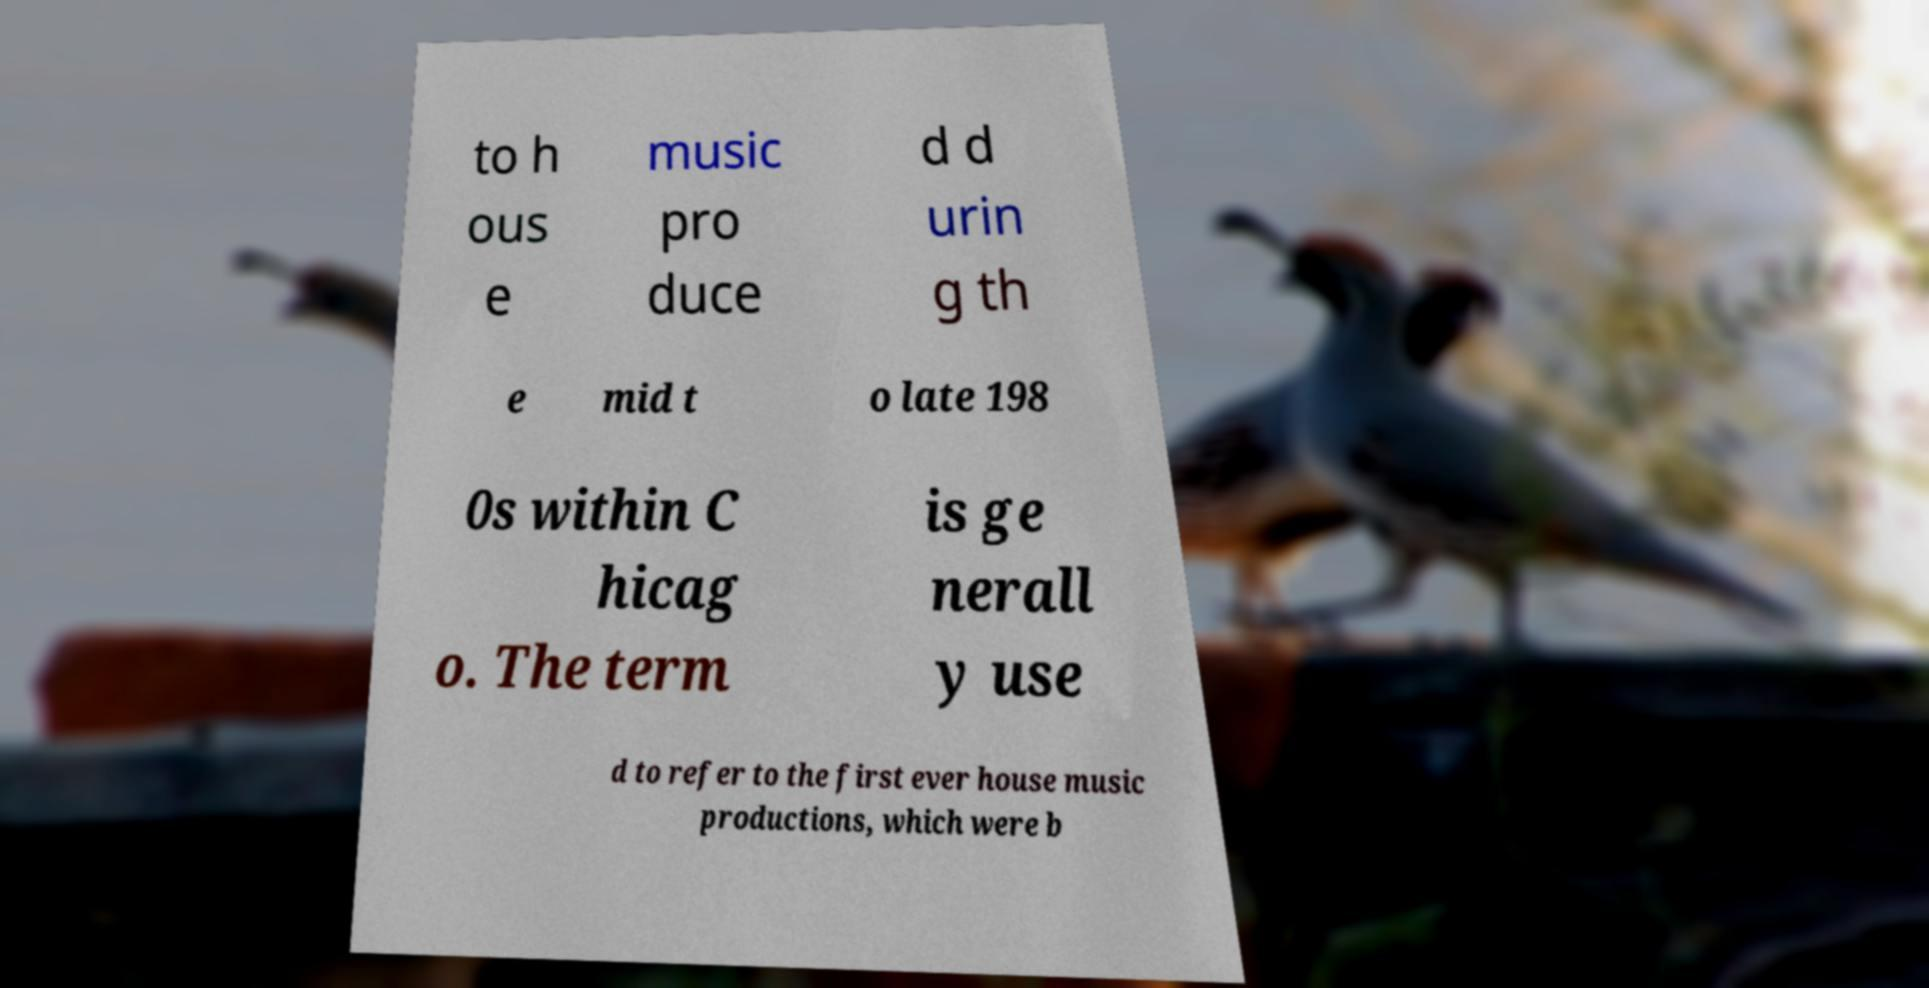Could you extract and type out the text from this image? to h ous e music pro duce d d urin g th e mid t o late 198 0s within C hicag o. The term is ge nerall y use d to refer to the first ever house music productions, which were b 